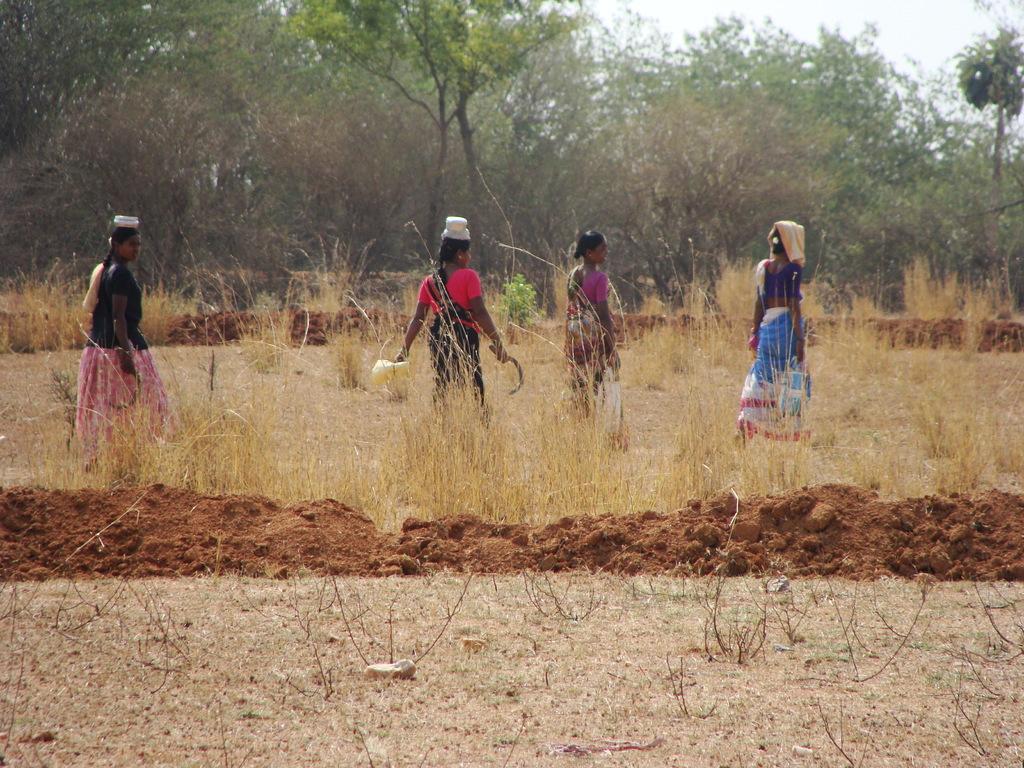Could you give a brief overview of what you see in this image? In the picture we can see some farmer woman standing in the crop, in the background, we can see some plants, trees and some parts of the sky. 